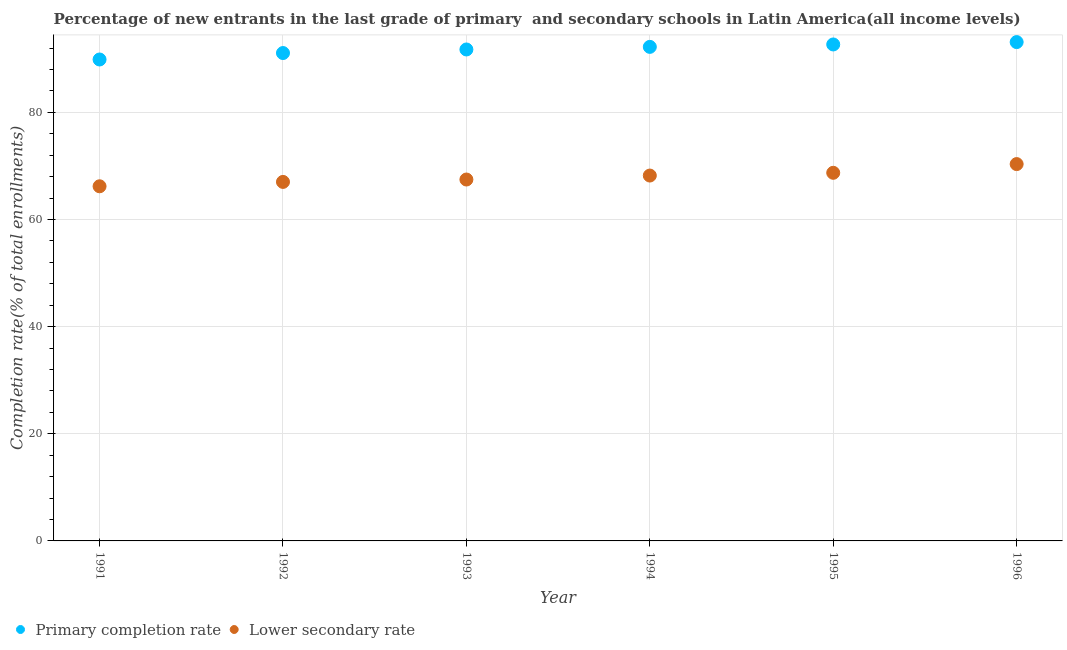How many different coloured dotlines are there?
Your answer should be very brief. 2. What is the completion rate in secondary schools in 1994?
Give a very brief answer. 68.19. Across all years, what is the maximum completion rate in primary schools?
Provide a succinct answer. 93.11. Across all years, what is the minimum completion rate in secondary schools?
Ensure brevity in your answer.  66.19. What is the total completion rate in primary schools in the graph?
Your answer should be compact. 550.63. What is the difference between the completion rate in primary schools in 1991 and that in 1996?
Offer a very short reply. -3.25. What is the difference between the completion rate in secondary schools in 1994 and the completion rate in primary schools in 1995?
Your answer should be very brief. -24.47. What is the average completion rate in primary schools per year?
Offer a terse response. 91.77. In the year 1994, what is the difference between the completion rate in primary schools and completion rate in secondary schools?
Your answer should be very brief. 24.02. In how many years, is the completion rate in primary schools greater than 52 %?
Give a very brief answer. 6. What is the ratio of the completion rate in secondary schools in 1991 to that in 1994?
Make the answer very short. 0.97. Is the completion rate in primary schools in 1992 less than that in 1994?
Offer a terse response. Yes. What is the difference between the highest and the second highest completion rate in secondary schools?
Give a very brief answer. 1.63. What is the difference between the highest and the lowest completion rate in primary schools?
Offer a terse response. 3.25. In how many years, is the completion rate in primary schools greater than the average completion rate in primary schools taken over all years?
Give a very brief answer. 3. Is the sum of the completion rate in secondary schools in 1991 and 1994 greater than the maximum completion rate in primary schools across all years?
Offer a terse response. Yes. Is the completion rate in primary schools strictly less than the completion rate in secondary schools over the years?
Your answer should be compact. No. What is the difference between two consecutive major ticks on the Y-axis?
Give a very brief answer. 20. Where does the legend appear in the graph?
Provide a succinct answer. Bottom left. What is the title of the graph?
Your answer should be compact. Percentage of new entrants in the last grade of primary  and secondary schools in Latin America(all income levels). What is the label or title of the X-axis?
Provide a short and direct response. Year. What is the label or title of the Y-axis?
Make the answer very short. Completion rate(% of total enrollments). What is the Completion rate(% of total enrollments) in Primary completion rate in 1991?
Offer a terse response. 89.86. What is the Completion rate(% of total enrollments) of Lower secondary rate in 1991?
Your answer should be compact. 66.19. What is the Completion rate(% of total enrollments) of Primary completion rate in 1992?
Ensure brevity in your answer.  91.06. What is the Completion rate(% of total enrollments) in Lower secondary rate in 1992?
Your answer should be very brief. 67.01. What is the Completion rate(% of total enrollments) of Primary completion rate in 1993?
Your response must be concise. 91.73. What is the Completion rate(% of total enrollments) in Lower secondary rate in 1993?
Offer a very short reply. 67.45. What is the Completion rate(% of total enrollments) in Primary completion rate in 1994?
Your answer should be compact. 92.21. What is the Completion rate(% of total enrollments) of Lower secondary rate in 1994?
Offer a very short reply. 68.19. What is the Completion rate(% of total enrollments) of Primary completion rate in 1995?
Offer a terse response. 92.66. What is the Completion rate(% of total enrollments) of Lower secondary rate in 1995?
Keep it short and to the point. 68.71. What is the Completion rate(% of total enrollments) in Primary completion rate in 1996?
Your answer should be very brief. 93.11. What is the Completion rate(% of total enrollments) in Lower secondary rate in 1996?
Your answer should be very brief. 70.33. Across all years, what is the maximum Completion rate(% of total enrollments) of Primary completion rate?
Your answer should be very brief. 93.11. Across all years, what is the maximum Completion rate(% of total enrollments) of Lower secondary rate?
Your answer should be very brief. 70.33. Across all years, what is the minimum Completion rate(% of total enrollments) in Primary completion rate?
Your answer should be very brief. 89.86. Across all years, what is the minimum Completion rate(% of total enrollments) in Lower secondary rate?
Make the answer very short. 66.19. What is the total Completion rate(% of total enrollments) of Primary completion rate in the graph?
Make the answer very short. 550.63. What is the total Completion rate(% of total enrollments) in Lower secondary rate in the graph?
Provide a short and direct response. 407.89. What is the difference between the Completion rate(% of total enrollments) of Primary completion rate in 1991 and that in 1992?
Give a very brief answer. -1.21. What is the difference between the Completion rate(% of total enrollments) in Lower secondary rate in 1991 and that in 1992?
Offer a very short reply. -0.81. What is the difference between the Completion rate(% of total enrollments) in Primary completion rate in 1991 and that in 1993?
Provide a succinct answer. -1.87. What is the difference between the Completion rate(% of total enrollments) in Lower secondary rate in 1991 and that in 1993?
Offer a terse response. -1.26. What is the difference between the Completion rate(% of total enrollments) of Primary completion rate in 1991 and that in 1994?
Provide a succinct answer. -2.36. What is the difference between the Completion rate(% of total enrollments) of Lower secondary rate in 1991 and that in 1994?
Keep it short and to the point. -2. What is the difference between the Completion rate(% of total enrollments) in Primary completion rate in 1991 and that in 1995?
Provide a succinct answer. -2.81. What is the difference between the Completion rate(% of total enrollments) in Lower secondary rate in 1991 and that in 1995?
Your answer should be very brief. -2.52. What is the difference between the Completion rate(% of total enrollments) in Primary completion rate in 1991 and that in 1996?
Your response must be concise. -3.25. What is the difference between the Completion rate(% of total enrollments) of Lower secondary rate in 1991 and that in 1996?
Your answer should be very brief. -4.14. What is the difference between the Completion rate(% of total enrollments) in Primary completion rate in 1992 and that in 1993?
Provide a short and direct response. -0.67. What is the difference between the Completion rate(% of total enrollments) in Lower secondary rate in 1992 and that in 1993?
Offer a terse response. -0.45. What is the difference between the Completion rate(% of total enrollments) of Primary completion rate in 1992 and that in 1994?
Provide a short and direct response. -1.15. What is the difference between the Completion rate(% of total enrollments) of Lower secondary rate in 1992 and that in 1994?
Your answer should be compact. -1.19. What is the difference between the Completion rate(% of total enrollments) of Primary completion rate in 1992 and that in 1995?
Provide a succinct answer. -1.6. What is the difference between the Completion rate(% of total enrollments) in Lower secondary rate in 1992 and that in 1995?
Give a very brief answer. -1.7. What is the difference between the Completion rate(% of total enrollments) of Primary completion rate in 1992 and that in 1996?
Ensure brevity in your answer.  -2.04. What is the difference between the Completion rate(% of total enrollments) in Lower secondary rate in 1992 and that in 1996?
Your answer should be very brief. -3.33. What is the difference between the Completion rate(% of total enrollments) of Primary completion rate in 1993 and that in 1994?
Provide a succinct answer. -0.49. What is the difference between the Completion rate(% of total enrollments) in Lower secondary rate in 1993 and that in 1994?
Your answer should be compact. -0.74. What is the difference between the Completion rate(% of total enrollments) of Primary completion rate in 1993 and that in 1995?
Ensure brevity in your answer.  -0.94. What is the difference between the Completion rate(% of total enrollments) in Lower secondary rate in 1993 and that in 1995?
Give a very brief answer. -1.25. What is the difference between the Completion rate(% of total enrollments) of Primary completion rate in 1993 and that in 1996?
Offer a terse response. -1.38. What is the difference between the Completion rate(% of total enrollments) in Lower secondary rate in 1993 and that in 1996?
Your answer should be compact. -2.88. What is the difference between the Completion rate(% of total enrollments) in Primary completion rate in 1994 and that in 1995?
Your answer should be compact. -0.45. What is the difference between the Completion rate(% of total enrollments) in Lower secondary rate in 1994 and that in 1995?
Offer a very short reply. -0.52. What is the difference between the Completion rate(% of total enrollments) of Primary completion rate in 1994 and that in 1996?
Offer a terse response. -0.89. What is the difference between the Completion rate(% of total enrollments) in Lower secondary rate in 1994 and that in 1996?
Make the answer very short. -2.14. What is the difference between the Completion rate(% of total enrollments) of Primary completion rate in 1995 and that in 1996?
Offer a very short reply. -0.44. What is the difference between the Completion rate(% of total enrollments) in Lower secondary rate in 1995 and that in 1996?
Offer a terse response. -1.63. What is the difference between the Completion rate(% of total enrollments) in Primary completion rate in 1991 and the Completion rate(% of total enrollments) in Lower secondary rate in 1992?
Provide a short and direct response. 22.85. What is the difference between the Completion rate(% of total enrollments) of Primary completion rate in 1991 and the Completion rate(% of total enrollments) of Lower secondary rate in 1993?
Your answer should be compact. 22.4. What is the difference between the Completion rate(% of total enrollments) of Primary completion rate in 1991 and the Completion rate(% of total enrollments) of Lower secondary rate in 1994?
Your answer should be compact. 21.66. What is the difference between the Completion rate(% of total enrollments) in Primary completion rate in 1991 and the Completion rate(% of total enrollments) in Lower secondary rate in 1995?
Give a very brief answer. 21.15. What is the difference between the Completion rate(% of total enrollments) in Primary completion rate in 1991 and the Completion rate(% of total enrollments) in Lower secondary rate in 1996?
Offer a very short reply. 19.52. What is the difference between the Completion rate(% of total enrollments) of Primary completion rate in 1992 and the Completion rate(% of total enrollments) of Lower secondary rate in 1993?
Your response must be concise. 23.61. What is the difference between the Completion rate(% of total enrollments) of Primary completion rate in 1992 and the Completion rate(% of total enrollments) of Lower secondary rate in 1994?
Give a very brief answer. 22.87. What is the difference between the Completion rate(% of total enrollments) in Primary completion rate in 1992 and the Completion rate(% of total enrollments) in Lower secondary rate in 1995?
Offer a terse response. 22.35. What is the difference between the Completion rate(% of total enrollments) in Primary completion rate in 1992 and the Completion rate(% of total enrollments) in Lower secondary rate in 1996?
Provide a short and direct response. 20.73. What is the difference between the Completion rate(% of total enrollments) of Primary completion rate in 1993 and the Completion rate(% of total enrollments) of Lower secondary rate in 1994?
Offer a very short reply. 23.53. What is the difference between the Completion rate(% of total enrollments) in Primary completion rate in 1993 and the Completion rate(% of total enrollments) in Lower secondary rate in 1995?
Offer a very short reply. 23.02. What is the difference between the Completion rate(% of total enrollments) of Primary completion rate in 1993 and the Completion rate(% of total enrollments) of Lower secondary rate in 1996?
Offer a terse response. 21.39. What is the difference between the Completion rate(% of total enrollments) of Primary completion rate in 1994 and the Completion rate(% of total enrollments) of Lower secondary rate in 1995?
Ensure brevity in your answer.  23.5. What is the difference between the Completion rate(% of total enrollments) in Primary completion rate in 1994 and the Completion rate(% of total enrollments) in Lower secondary rate in 1996?
Your answer should be very brief. 21.88. What is the difference between the Completion rate(% of total enrollments) of Primary completion rate in 1995 and the Completion rate(% of total enrollments) of Lower secondary rate in 1996?
Offer a terse response. 22.33. What is the average Completion rate(% of total enrollments) of Primary completion rate per year?
Make the answer very short. 91.77. What is the average Completion rate(% of total enrollments) of Lower secondary rate per year?
Give a very brief answer. 67.98. In the year 1991, what is the difference between the Completion rate(% of total enrollments) in Primary completion rate and Completion rate(% of total enrollments) in Lower secondary rate?
Ensure brevity in your answer.  23.66. In the year 1992, what is the difference between the Completion rate(% of total enrollments) in Primary completion rate and Completion rate(% of total enrollments) in Lower secondary rate?
Your answer should be compact. 24.05. In the year 1993, what is the difference between the Completion rate(% of total enrollments) of Primary completion rate and Completion rate(% of total enrollments) of Lower secondary rate?
Offer a very short reply. 24.27. In the year 1994, what is the difference between the Completion rate(% of total enrollments) of Primary completion rate and Completion rate(% of total enrollments) of Lower secondary rate?
Ensure brevity in your answer.  24.02. In the year 1995, what is the difference between the Completion rate(% of total enrollments) in Primary completion rate and Completion rate(% of total enrollments) in Lower secondary rate?
Provide a succinct answer. 23.95. In the year 1996, what is the difference between the Completion rate(% of total enrollments) of Primary completion rate and Completion rate(% of total enrollments) of Lower secondary rate?
Ensure brevity in your answer.  22.77. What is the ratio of the Completion rate(% of total enrollments) of Lower secondary rate in 1991 to that in 1992?
Provide a short and direct response. 0.99. What is the ratio of the Completion rate(% of total enrollments) in Primary completion rate in 1991 to that in 1993?
Make the answer very short. 0.98. What is the ratio of the Completion rate(% of total enrollments) in Lower secondary rate in 1991 to that in 1993?
Provide a short and direct response. 0.98. What is the ratio of the Completion rate(% of total enrollments) in Primary completion rate in 1991 to that in 1994?
Offer a terse response. 0.97. What is the ratio of the Completion rate(% of total enrollments) in Lower secondary rate in 1991 to that in 1994?
Provide a succinct answer. 0.97. What is the ratio of the Completion rate(% of total enrollments) of Primary completion rate in 1991 to that in 1995?
Offer a very short reply. 0.97. What is the ratio of the Completion rate(% of total enrollments) in Lower secondary rate in 1991 to that in 1995?
Give a very brief answer. 0.96. What is the ratio of the Completion rate(% of total enrollments) of Primary completion rate in 1991 to that in 1996?
Offer a very short reply. 0.97. What is the ratio of the Completion rate(% of total enrollments) of Lower secondary rate in 1991 to that in 1996?
Provide a succinct answer. 0.94. What is the ratio of the Completion rate(% of total enrollments) in Lower secondary rate in 1992 to that in 1993?
Provide a short and direct response. 0.99. What is the ratio of the Completion rate(% of total enrollments) in Primary completion rate in 1992 to that in 1994?
Your answer should be very brief. 0.99. What is the ratio of the Completion rate(% of total enrollments) of Lower secondary rate in 1992 to that in 1994?
Keep it short and to the point. 0.98. What is the ratio of the Completion rate(% of total enrollments) in Primary completion rate in 1992 to that in 1995?
Make the answer very short. 0.98. What is the ratio of the Completion rate(% of total enrollments) of Lower secondary rate in 1992 to that in 1995?
Offer a very short reply. 0.98. What is the ratio of the Completion rate(% of total enrollments) in Primary completion rate in 1992 to that in 1996?
Ensure brevity in your answer.  0.98. What is the ratio of the Completion rate(% of total enrollments) of Lower secondary rate in 1992 to that in 1996?
Make the answer very short. 0.95. What is the ratio of the Completion rate(% of total enrollments) of Lower secondary rate in 1993 to that in 1995?
Your answer should be compact. 0.98. What is the ratio of the Completion rate(% of total enrollments) of Primary completion rate in 1993 to that in 1996?
Offer a very short reply. 0.99. What is the ratio of the Completion rate(% of total enrollments) in Lower secondary rate in 1993 to that in 1996?
Offer a very short reply. 0.96. What is the ratio of the Completion rate(% of total enrollments) in Primary completion rate in 1994 to that in 1995?
Provide a short and direct response. 1. What is the ratio of the Completion rate(% of total enrollments) in Lower secondary rate in 1994 to that in 1995?
Your answer should be very brief. 0.99. What is the ratio of the Completion rate(% of total enrollments) of Lower secondary rate in 1994 to that in 1996?
Provide a short and direct response. 0.97. What is the ratio of the Completion rate(% of total enrollments) in Primary completion rate in 1995 to that in 1996?
Make the answer very short. 1. What is the ratio of the Completion rate(% of total enrollments) in Lower secondary rate in 1995 to that in 1996?
Ensure brevity in your answer.  0.98. What is the difference between the highest and the second highest Completion rate(% of total enrollments) of Primary completion rate?
Your answer should be compact. 0.44. What is the difference between the highest and the second highest Completion rate(% of total enrollments) in Lower secondary rate?
Give a very brief answer. 1.63. What is the difference between the highest and the lowest Completion rate(% of total enrollments) of Primary completion rate?
Provide a succinct answer. 3.25. What is the difference between the highest and the lowest Completion rate(% of total enrollments) of Lower secondary rate?
Give a very brief answer. 4.14. 